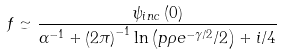<formula> <loc_0><loc_0><loc_500><loc_500>f \simeq \frac { \psi _ { i n c } \left ( 0 \right ) } { \alpha ^ { - 1 } + \left ( 2 \pi \right ) ^ { - 1 } \ln \left ( p \rho e ^ { - \gamma / 2 } / 2 \right ) + i / 4 }</formula> 